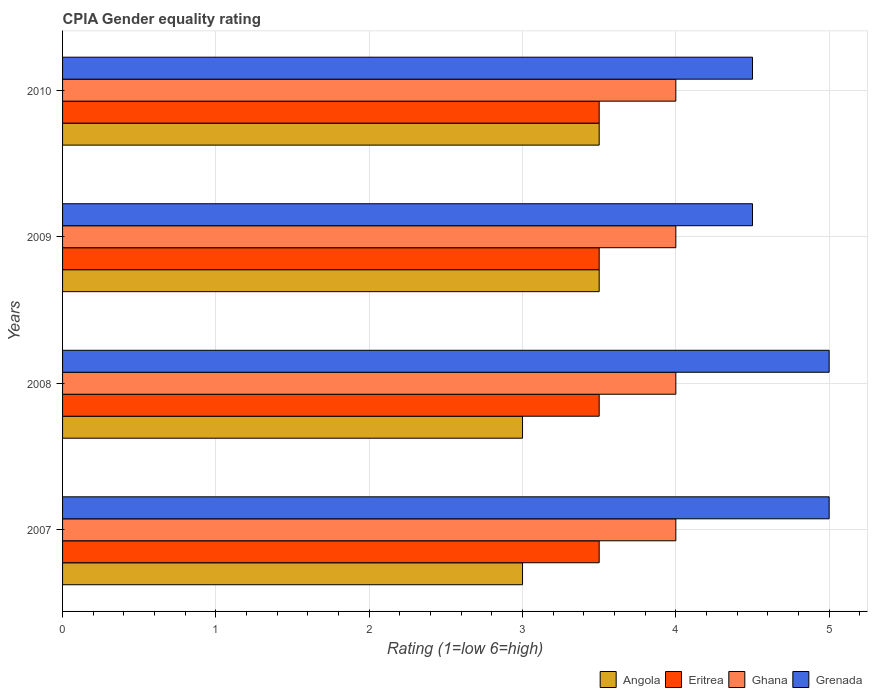How many different coloured bars are there?
Keep it short and to the point. 4. How many bars are there on the 4th tick from the top?
Keep it short and to the point. 4. In how many cases, is the number of bars for a given year not equal to the number of legend labels?
Provide a succinct answer. 0. What is the CPIA rating in Ghana in 2009?
Your answer should be compact. 4. In which year was the CPIA rating in Eritrea maximum?
Provide a succinct answer. 2007. In which year was the CPIA rating in Ghana minimum?
Your answer should be very brief. 2007. What is the total CPIA rating in Angola in the graph?
Make the answer very short. 13. What is the difference between the CPIA rating in Grenada in 2009 and the CPIA rating in Eritrea in 2007?
Offer a terse response. 1. What is the average CPIA rating in Grenada per year?
Provide a succinct answer. 4.75. In the year 2008, what is the difference between the CPIA rating in Grenada and CPIA rating in Eritrea?
Keep it short and to the point. 1.5. Is the CPIA rating in Grenada in 2007 less than that in 2008?
Provide a short and direct response. No. Is the difference between the CPIA rating in Grenada in 2008 and 2010 greater than the difference between the CPIA rating in Eritrea in 2008 and 2010?
Provide a short and direct response. Yes. Is the sum of the CPIA rating in Eritrea in 2008 and 2009 greater than the maximum CPIA rating in Angola across all years?
Ensure brevity in your answer.  Yes. What does the 3rd bar from the top in 2010 represents?
Keep it short and to the point. Eritrea. What does the 4th bar from the bottom in 2009 represents?
Provide a succinct answer. Grenada. Are all the bars in the graph horizontal?
Ensure brevity in your answer.  Yes. Does the graph contain any zero values?
Give a very brief answer. No. Where does the legend appear in the graph?
Offer a very short reply. Bottom right. How many legend labels are there?
Your answer should be very brief. 4. What is the title of the graph?
Ensure brevity in your answer.  CPIA Gender equality rating. Does "Chile" appear as one of the legend labels in the graph?
Your answer should be compact. No. What is the Rating (1=low 6=high) of Angola in 2007?
Make the answer very short. 3. What is the Rating (1=low 6=high) of Grenada in 2007?
Your answer should be compact. 5. What is the Rating (1=low 6=high) of Eritrea in 2008?
Make the answer very short. 3.5. What is the Rating (1=low 6=high) in Grenada in 2008?
Give a very brief answer. 5. What is the Rating (1=low 6=high) of Eritrea in 2009?
Make the answer very short. 3.5. What is the Rating (1=low 6=high) in Grenada in 2009?
Ensure brevity in your answer.  4.5. What is the Rating (1=low 6=high) in Eritrea in 2010?
Offer a very short reply. 3.5. What is the Rating (1=low 6=high) in Grenada in 2010?
Ensure brevity in your answer.  4.5. Across all years, what is the maximum Rating (1=low 6=high) in Angola?
Ensure brevity in your answer.  3.5. Across all years, what is the maximum Rating (1=low 6=high) in Ghana?
Your response must be concise. 4. Across all years, what is the minimum Rating (1=low 6=high) of Angola?
Your response must be concise. 3. Across all years, what is the minimum Rating (1=low 6=high) in Ghana?
Offer a terse response. 4. Across all years, what is the minimum Rating (1=low 6=high) of Grenada?
Give a very brief answer. 4.5. What is the total Rating (1=low 6=high) in Eritrea in the graph?
Offer a terse response. 14. What is the difference between the Rating (1=low 6=high) in Ghana in 2007 and that in 2008?
Keep it short and to the point. 0. What is the difference between the Rating (1=low 6=high) in Angola in 2007 and that in 2009?
Give a very brief answer. -0.5. What is the difference between the Rating (1=low 6=high) in Grenada in 2007 and that in 2009?
Make the answer very short. 0.5. What is the difference between the Rating (1=low 6=high) in Eritrea in 2007 and that in 2010?
Give a very brief answer. 0. What is the difference between the Rating (1=low 6=high) of Grenada in 2007 and that in 2010?
Offer a very short reply. 0.5. What is the difference between the Rating (1=low 6=high) in Eritrea in 2008 and that in 2009?
Provide a succinct answer. 0. What is the difference between the Rating (1=low 6=high) of Grenada in 2008 and that in 2009?
Provide a succinct answer. 0.5. What is the difference between the Rating (1=low 6=high) in Eritrea in 2008 and that in 2010?
Keep it short and to the point. 0. What is the difference between the Rating (1=low 6=high) in Eritrea in 2009 and that in 2010?
Keep it short and to the point. 0. What is the difference between the Rating (1=low 6=high) of Ghana in 2009 and that in 2010?
Provide a short and direct response. 0. What is the difference between the Rating (1=low 6=high) in Grenada in 2009 and that in 2010?
Give a very brief answer. 0. What is the difference between the Rating (1=low 6=high) in Angola in 2007 and the Rating (1=low 6=high) in Eritrea in 2008?
Keep it short and to the point. -0.5. What is the difference between the Rating (1=low 6=high) in Angola in 2007 and the Rating (1=low 6=high) in Eritrea in 2009?
Your answer should be very brief. -0.5. What is the difference between the Rating (1=low 6=high) of Angola in 2007 and the Rating (1=low 6=high) of Ghana in 2009?
Make the answer very short. -1. What is the difference between the Rating (1=low 6=high) in Angola in 2007 and the Rating (1=low 6=high) in Grenada in 2009?
Your response must be concise. -1.5. What is the difference between the Rating (1=low 6=high) of Eritrea in 2007 and the Rating (1=low 6=high) of Ghana in 2009?
Make the answer very short. -0.5. What is the difference between the Rating (1=low 6=high) in Eritrea in 2007 and the Rating (1=low 6=high) in Grenada in 2009?
Offer a terse response. -1. What is the difference between the Rating (1=low 6=high) in Ghana in 2007 and the Rating (1=low 6=high) in Grenada in 2009?
Your response must be concise. -0.5. What is the difference between the Rating (1=low 6=high) of Angola in 2007 and the Rating (1=low 6=high) of Eritrea in 2010?
Make the answer very short. -0.5. What is the difference between the Rating (1=low 6=high) of Angola in 2007 and the Rating (1=low 6=high) of Ghana in 2010?
Provide a short and direct response. -1. What is the difference between the Rating (1=low 6=high) of Angola in 2007 and the Rating (1=low 6=high) of Grenada in 2010?
Provide a succinct answer. -1.5. What is the difference between the Rating (1=low 6=high) of Ghana in 2007 and the Rating (1=low 6=high) of Grenada in 2010?
Offer a very short reply. -0.5. What is the difference between the Rating (1=low 6=high) of Angola in 2008 and the Rating (1=low 6=high) of Ghana in 2009?
Provide a succinct answer. -1. What is the difference between the Rating (1=low 6=high) in Angola in 2008 and the Rating (1=low 6=high) in Grenada in 2009?
Offer a very short reply. -1.5. What is the difference between the Rating (1=low 6=high) of Eritrea in 2008 and the Rating (1=low 6=high) of Ghana in 2010?
Make the answer very short. -0.5. What is the difference between the Rating (1=low 6=high) of Eritrea in 2009 and the Rating (1=low 6=high) of Ghana in 2010?
Your answer should be very brief. -0.5. What is the difference between the Rating (1=low 6=high) of Eritrea in 2009 and the Rating (1=low 6=high) of Grenada in 2010?
Make the answer very short. -1. What is the difference between the Rating (1=low 6=high) of Ghana in 2009 and the Rating (1=low 6=high) of Grenada in 2010?
Provide a short and direct response. -0.5. What is the average Rating (1=low 6=high) of Angola per year?
Your answer should be compact. 3.25. What is the average Rating (1=low 6=high) of Eritrea per year?
Provide a short and direct response. 3.5. What is the average Rating (1=low 6=high) of Grenada per year?
Keep it short and to the point. 4.75. In the year 2007, what is the difference between the Rating (1=low 6=high) of Angola and Rating (1=low 6=high) of Eritrea?
Your answer should be very brief. -0.5. In the year 2007, what is the difference between the Rating (1=low 6=high) in Eritrea and Rating (1=low 6=high) in Grenada?
Your answer should be very brief. -1.5. In the year 2007, what is the difference between the Rating (1=low 6=high) in Ghana and Rating (1=low 6=high) in Grenada?
Keep it short and to the point. -1. In the year 2008, what is the difference between the Rating (1=low 6=high) of Angola and Rating (1=low 6=high) of Ghana?
Your answer should be very brief. -1. In the year 2008, what is the difference between the Rating (1=low 6=high) of Angola and Rating (1=low 6=high) of Grenada?
Make the answer very short. -2. In the year 2009, what is the difference between the Rating (1=low 6=high) in Eritrea and Rating (1=low 6=high) in Ghana?
Make the answer very short. -0.5. In the year 2010, what is the difference between the Rating (1=low 6=high) in Angola and Rating (1=low 6=high) in Eritrea?
Your answer should be very brief. 0. In the year 2010, what is the difference between the Rating (1=low 6=high) of Angola and Rating (1=low 6=high) of Grenada?
Provide a succinct answer. -1. In the year 2010, what is the difference between the Rating (1=low 6=high) in Eritrea and Rating (1=low 6=high) in Ghana?
Provide a succinct answer. -0.5. In the year 2010, what is the difference between the Rating (1=low 6=high) in Eritrea and Rating (1=low 6=high) in Grenada?
Offer a very short reply. -1. What is the ratio of the Rating (1=low 6=high) in Angola in 2007 to that in 2008?
Offer a very short reply. 1. What is the ratio of the Rating (1=low 6=high) of Ghana in 2007 to that in 2008?
Ensure brevity in your answer.  1. What is the ratio of the Rating (1=low 6=high) of Angola in 2007 to that in 2009?
Offer a very short reply. 0.86. What is the ratio of the Rating (1=low 6=high) of Eritrea in 2007 to that in 2010?
Your answer should be compact. 1. What is the ratio of the Rating (1=low 6=high) of Ghana in 2007 to that in 2010?
Make the answer very short. 1. What is the ratio of the Rating (1=low 6=high) of Angola in 2008 to that in 2009?
Provide a succinct answer. 0.86. What is the ratio of the Rating (1=low 6=high) in Eritrea in 2008 to that in 2009?
Offer a very short reply. 1. What is the ratio of the Rating (1=low 6=high) in Grenada in 2008 to that in 2009?
Your answer should be very brief. 1.11. What is the ratio of the Rating (1=low 6=high) of Angola in 2008 to that in 2010?
Make the answer very short. 0.86. What is the ratio of the Rating (1=low 6=high) of Grenada in 2008 to that in 2010?
Your answer should be very brief. 1.11. What is the ratio of the Rating (1=low 6=high) in Angola in 2009 to that in 2010?
Ensure brevity in your answer.  1. What is the ratio of the Rating (1=low 6=high) in Eritrea in 2009 to that in 2010?
Offer a very short reply. 1. What is the ratio of the Rating (1=low 6=high) of Ghana in 2009 to that in 2010?
Provide a short and direct response. 1. What is the ratio of the Rating (1=low 6=high) of Grenada in 2009 to that in 2010?
Your answer should be very brief. 1. What is the difference between the highest and the lowest Rating (1=low 6=high) in Ghana?
Offer a terse response. 0. What is the difference between the highest and the lowest Rating (1=low 6=high) in Grenada?
Provide a short and direct response. 0.5. 